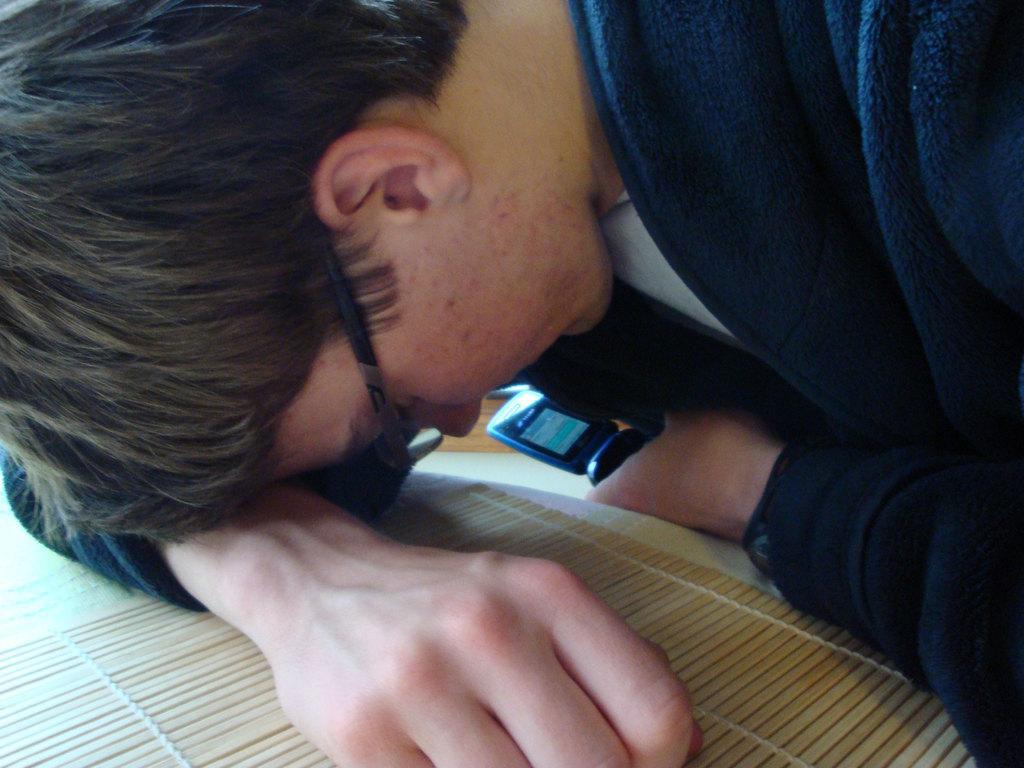Could you give a brief overview of what you see in this image? In this image there is a man leaning his hand on the table and he is holding a mobile phone in his hand. At the bottom of the image there is a table with a table runner on it. 